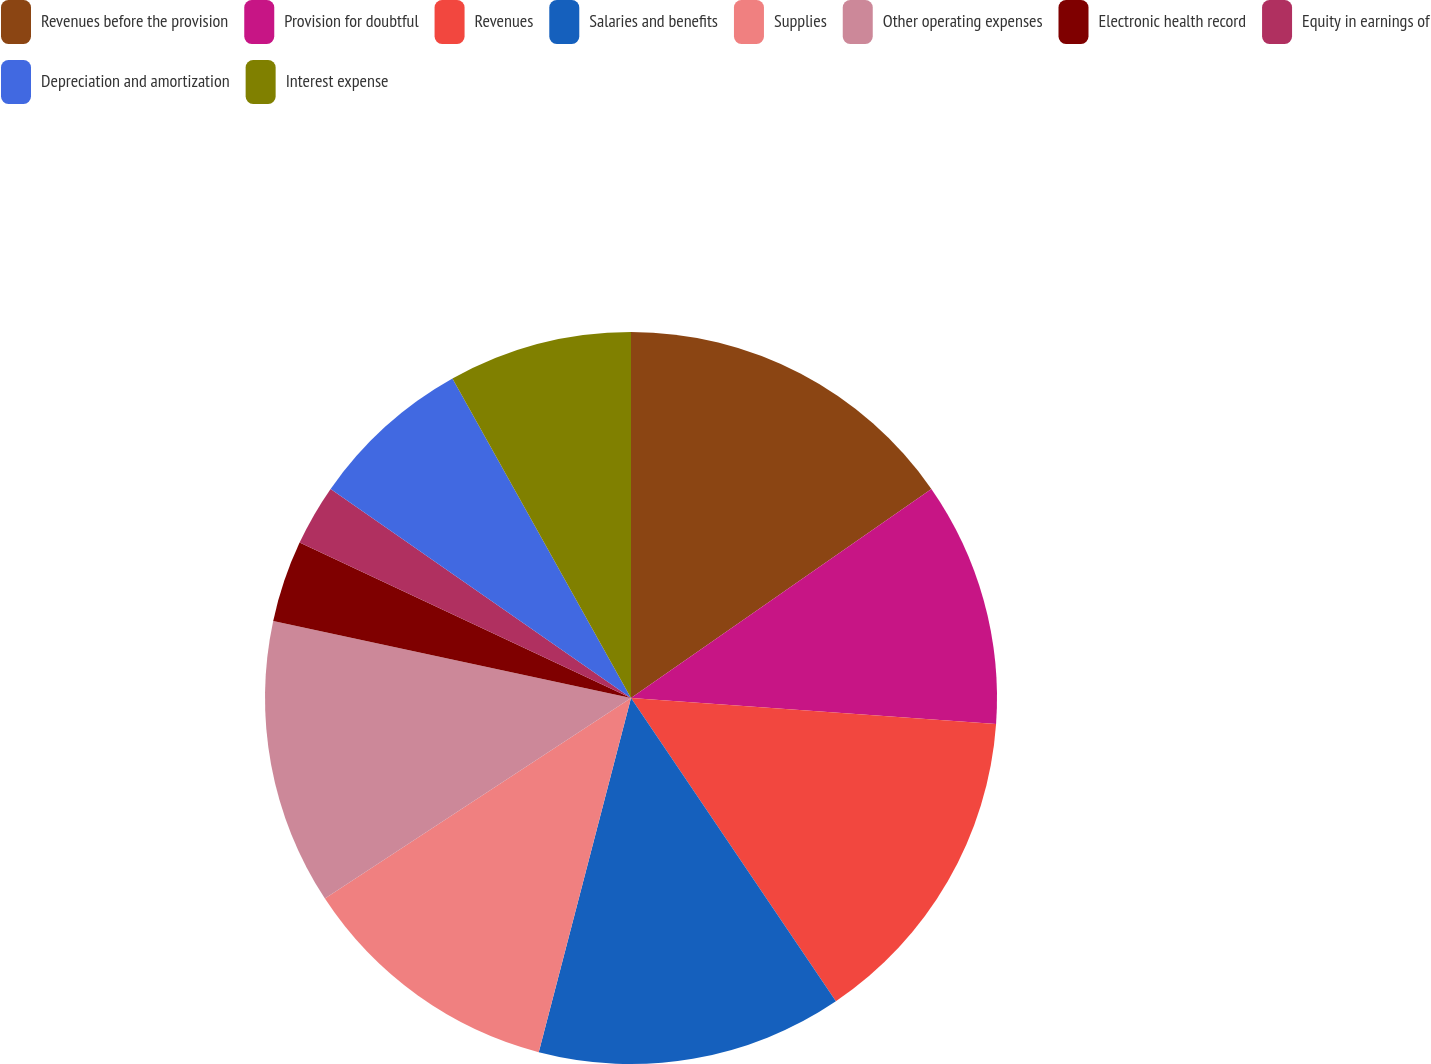Convert chart to OTSL. <chart><loc_0><loc_0><loc_500><loc_500><pie_chart><fcel>Revenues before the provision<fcel>Provision for doubtful<fcel>Revenues<fcel>Salaries and benefits<fcel>Supplies<fcel>Other operating expenses<fcel>Electronic health record<fcel>Equity in earnings of<fcel>Depreciation and amortization<fcel>Interest expense<nl><fcel>15.32%<fcel>10.81%<fcel>14.41%<fcel>13.51%<fcel>11.71%<fcel>12.61%<fcel>3.6%<fcel>2.7%<fcel>7.21%<fcel>8.11%<nl></chart> 